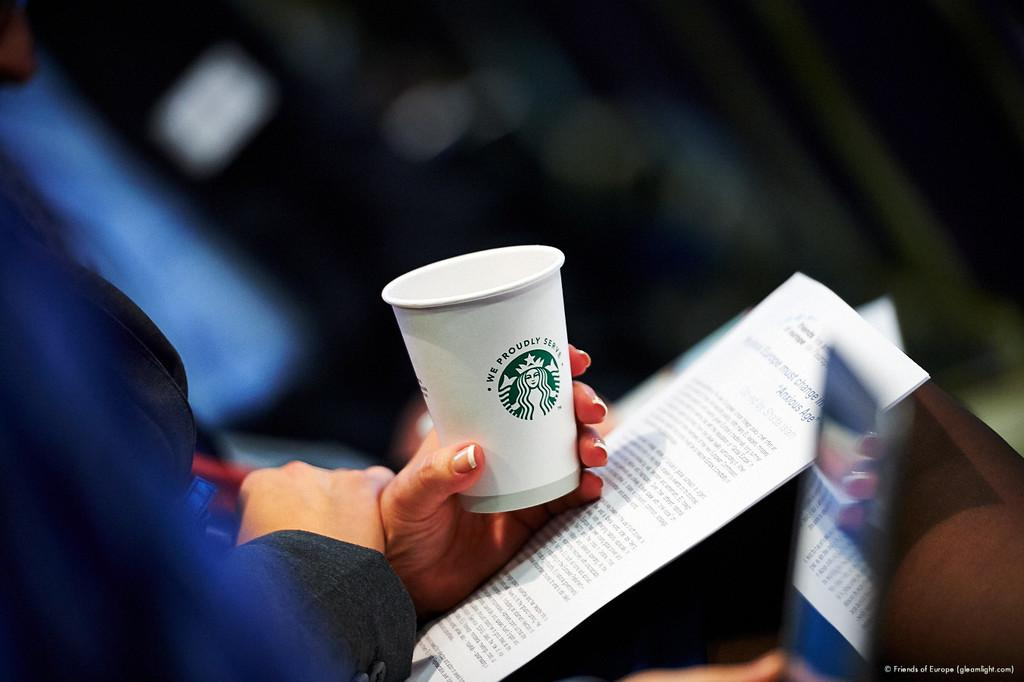What is the main subject of the image? There is a person sitting in the middle of the image. What is the person holding in the image? The person is holding a paper and a cup. Can you describe the person's actions or activities in the image? The person is sitting and holding a paper and a cup. What is the condition of the top part of the image? The top of the image is blurry. What type of plant is being raked in the image? There is no plant or rake present in the image. How many cabbages are visible in the image? There are no cabbages present in the image. 